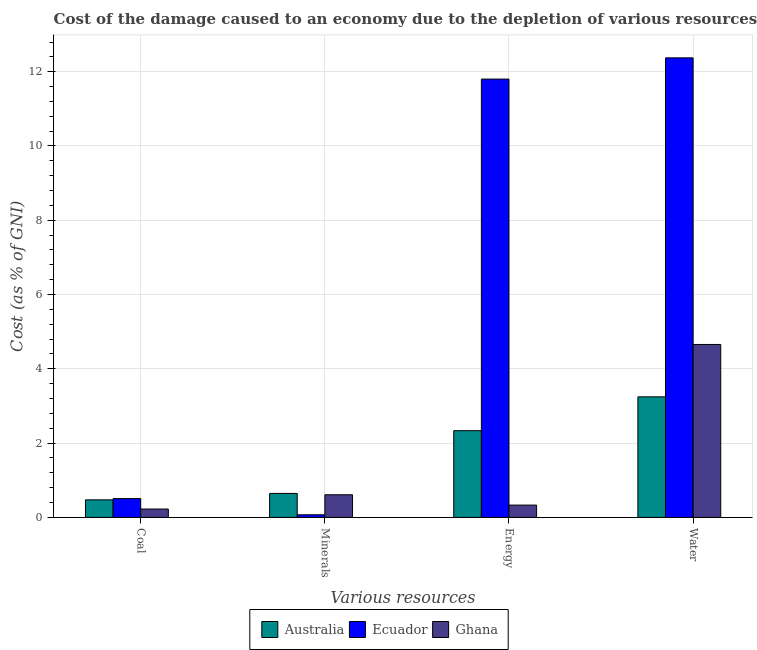How many different coloured bars are there?
Your answer should be compact. 3. What is the label of the 1st group of bars from the left?
Keep it short and to the point. Coal. What is the cost of damage due to depletion of minerals in Ecuador?
Make the answer very short. 0.07. Across all countries, what is the maximum cost of damage due to depletion of energy?
Offer a terse response. 11.8. Across all countries, what is the minimum cost of damage due to depletion of energy?
Offer a terse response. 0.33. In which country was the cost of damage due to depletion of coal maximum?
Offer a terse response. Ecuador. In which country was the cost of damage due to depletion of minerals minimum?
Give a very brief answer. Ecuador. What is the total cost of damage due to depletion of energy in the graph?
Offer a very short reply. 14.47. What is the difference between the cost of damage due to depletion of energy in Ecuador and that in Australia?
Offer a very short reply. 9.47. What is the difference between the cost of damage due to depletion of energy in Ghana and the cost of damage due to depletion of water in Ecuador?
Provide a short and direct response. -12.04. What is the average cost of damage due to depletion of minerals per country?
Ensure brevity in your answer.  0.44. What is the difference between the cost of damage due to depletion of water and cost of damage due to depletion of minerals in Australia?
Keep it short and to the point. 2.6. What is the ratio of the cost of damage due to depletion of water in Ecuador to that in Ghana?
Ensure brevity in your answer.  2.66. What is the difference between the highest and the second highest cost of damage due to depletion of energy?
Your answer should be very brief. 9.47. What is the difference between the highest and the lowest cost of damage due to depletion of water?
Your answer should be compact. 9.13. In how many countries, is the cost of damage due to depletion of energy greater than the average cost of damage due to depletion of energy taken over all countries?
Your answer should be very brief. 1. Is the sum of the cost of damage due to depletion of water in Australia and Ecuador greater than the maximum cost of damage due to depletion of minerals across all countries?
Your response must be concise. Yes. Is it the case that in every country, the sum of the cost of damage due to depletion of minerals and cost of damage due to depletion of coal is greater than the sum of cost of damage due to depletion of energy and cost of damage due to depletion of water?
Your answer should be compact. No. What does the 1st bar from the right in Energy represents?
Ensure brevity in your answer.  Ghana. Is it the case that in every country, the sum of the cost of damage due to depletion of coal and cost of damage due to depletion of minerals is greater than the cost of damage due to depletion of energy?
Your answer should be very brief. No. Are all the bars in the graph horizontal?
Give a very brief answer. No. How many countries are there in the graph?
Make the answer very short. 3. What is the difference between two consecutive major ticks on the Y-axis?
Provide a succinct answer. 2. Does the graph contain any zero values?
Keep it short and to the point. No. Does the graph contain grids?
Your answer should be compact. Yes. How are the legend labels stacked?
Keep it short and to the point. Horizontal. What is the title of the graph?
Your answer should be very brief. Cost of the damage caused to an economy due to the depletion of various resources in 1984 . Does "Bermuda" appear as one of the legend labels in the graph?
Provide a short and direct response. No. What is the label or title of the X-axis?
Your response must be concise. Various resources. What is the label or title of the Y-axis?
Keep it short and to the point. Cost (as % of GNI). What is the Cost (as % of GNI) in Australia in Coal?
Make the answer very short. 0.47. What is the Cost (as % of GNI) in Ecuador in Coal?
Provide a short and direct response. 0.51. What is the Cost (as % of GNI) in Ghana in Coal?
Give a very brief answer. 0.23. What is the Cost (as % of GNI) of Australia in Minerals?
Offer a terse response. 0.65. What is the Cost (as % of GNI) of Ecuador in Minerals?
Your answer should be very brief. 0.07. What is the Cost (as % of GNI) of Ghana in Minerals?
Your answer should be very brief. 0.61. What is the Cost (as % of GNI) of Australia in Energy?
Offer a terse response. 2.33. What is the Cost (as % of GNI) in Ecuador in Energy?
Give a very brief answer. 11.8. What is the Cost (as % of GNI) of Ghana in Energy?
Make the answer very short. 0.33. What is the Cost (as % of GNI) in Australia in Water?
Provide a short and direct response. 3.25. What is the Cost (as % of GNI) of Ecuador in Water?
Provide a succinct answer. 12.37. What is the Cost (as % of GNI) in Ghana in Water?
Your answer should be compact. 4.66. Across all Various resources, what is the maximum Cost (as % of GNI) in Australia?
Your answer should be compact. 3.25. Across all Various resources, what is the maximum Cost (as % of GNI) of Ecuador?
Keep it short and to the point. 12.37. Across all Various resources, what is the maximum Cost (as % of GNI) in Ghana?
Offer a very short reply. 4.66. Across all Various resources, what is the minimum Cost (as % of GNI) of Australia?
Ensure brevity in your answer.  0.47. Across all Various resources, what is the minimum Cost (as % of GNI) of Ecuador?
Provide a succinct answer. 0.07. Across all Various resources, what is the minimum Cost (as % of GNI) of Ghana?
Provide a short and direct response. 0.23. What is the total Cost (as % of GNI) in Australia in the graph?
Offer a terse response. 6.7. What is the total Cost (as % of GNI) of Ecuador in the graph?
Your answer should be compact. 24.75. What is the total Cost (as % of GNI) in Ghana in the graph?
Keep it short and to the point. 5.83. What is the difference between the Cost (as % of GNI) in Australia in Coal and that in Minerals?
Your answer should be very brief. -0.17. What is the difference between the Cost (as % of GNI) in Ecuador in Coal and that in Minerals?
Give a very brief answer. 0.44. What is the difference between the Cost (as % of GNI) of Ghana in Coal and that in Minerals?
Offer a very short reply. -0.38. What is the difference between the Cost (as % of GNI) of Australia in Coal and that in Energy?
Give a very brief answer. -1.86. What is the difference between the Cost (as % of GNI) of Ecuador in Coal and that in Energy?
Your answer should be very brief. -11.3. What is the difference between the Cost (as % of GNI) of Ghana in Coal and that in Energy?
Provide a succinct answer. -0.11. What is the difference between the Cost (as % of GNI) of Australia in Coal and that in Water?
Your answer should be very brief. -2.77. What is the difference between the Cost (as % of GNI) of Ecuador in Coal and that in Water?
Your answer should be compact. -11.87. What is the difference between the Cost (as % of GNI) of Ghana in Coal and that in Water?
Your answer should be compact. -4.43. What is the difference between the Cost (as % of GNI) of Australia in Minerals and that in Energy?
Provide a succinct answer. -1.69. What is the difference between the Cost (as % of GNI) in Ecuador in Minerals and that in Energy?
Provide a short and direct response. -11.73. What is the difference between the Cost (as % of GNI) of Ghana in Minerals and that in Energy?
Keep it short and to the point. 0.28. What is the difference between the Cost (as % of GNI) of Australia in Minerals and that in Water?
Offer a very short reply. -2.6. What is the difference between the Cost (as % of GNI) of Ecuador in Minerals and that in Water?
Make the answer very short. -12.3. What is the difference between the Cost (as % of GNI) of Ghana in Minerals and that in Water?
Offer a terse response. -4.05. What is the difference between the Cost (as % of GNI) of Australia in Energy and that in Water?
Keep it short and to the point. -0.91. What is the difference between the Cost (as % of GNI) in Ecuador in Energy and that in Water?
Your answer should be very brief. -0.57. What is the difference between the Cost (as % of GNI) of Ghana in Energy and that in Water?
Keep it short and to the point. -4.32. What is the difference between the Cost (as % of GNI) in Australia in Coal and the Cost (as % of GNI) in Ecuador in Minerals?
Provide a succinct answer. 0.4. What is the difference between the Cost (as % of GNI) in Australia in Coal and the Cost (as % of GNI) in Ghana in Minerals?
Ensure brevity in your answer.  -0.14. What is the difference between the Cost (as % of GNI) in Ecuador in Coal and the Cost (as % of GNI) in Ghana in Minerals?
Provide a short and direct response. -0.1. What is the difference between the Cost (as % of GNI) of Australia in Coal and the Cost (as % of GNI) of Ecuador in Energy?
Make the answer very short. -11.33. What is the difference between the Cost (as % of GNI) in Australia in Coal and the Cost (as % of GNI) in Ghana in Energy?
Provide a succinct answer. 0.14. What is the difference between the Cost (as % of GNI) in Ecuador in Coal and the Cost (as % of GNI) in Ghana in Energy?
Keep it short and to the point. 0.17. What is the difference between the Cost (as % of GNI) of Australia in Coal and the Cost (as % of GNI) of Ecuador in Water?
Give a very brief answer. -11.9. What is the difference between the Cost (as % of GNI) in Australia in Coal and the Cost (as % of GNI) in Ghana in Water?
Keep it short and to the point. -4.18. What is the difference between the Cost (as % of GNI) in Ecuador in Coal and the Cost (as % of GNI) in Ghana in Water?
Your response must be concise. -4.15. What is the difference between the Cost (as % of GNI) in Australia in Minerals and the Cost (as % of GNI) in Ecuador in Energy?
Make the answer very short. -11.16. What is the difference between the Cost (as % of GNI) in Australia in Minerals and the Cost (as % of GNI) in Ghana in Energy?
Your answer should be compact. 0.31. What is the difference between the Cost (as % of GNI) of Ecuador in Minerals and the Cost (as % of GNI) of Ghana in Energy?
Your answer should be compact. -0.26. What is the difference between the Cost (as % of GNI) in Australia in Minerals and the Cost (as % of GNI) in Ecuador in Water?
Offer a very short reply. -11.73. What is the difference between the Cost (as % of GNI) of Australia in Minerals and the Cost (as % of GNI) of Ghana in Water?
Your answer should be very brief. -4.01. What is the difference between the Cost (as % of GNI) in Ecuador in Minerals and the Cost (as % of GNI) in Ghana in Water?
Keep it short and to the point. -4.59. What is the difference between the Cost (as % of GNI) in Australia in Energy and the Cost (as % of GNI) in Ecuador in Water?
Your response must be concise. -10.04. What is the difference between the Cost (as % of GNI) in Australia in Energy and the Cost (as % of GNI) in Ghana in Water?
Your answer should be compact. -2.32. What is the difference between the Cost (as % of GNI) in Ecuador in Energy and the Cost (as % of GNI) in Ghana in Water?
Make the answer very short. 7.14. What is the average Cost (as % of GNI) of Australia per Various resources?
Offer a terse response. 1.68. What is the average Cost (as % of GNI) of Ecuador per Various resources?
Provide a succinct answer. 6.19. What is the average Cost (as % of GNI) in Ghana per Various resources?
Your response must be concise. 1.46. What is the difference between the Cost (as % of GNI) in Australia and Cost (as % of GNI) in Ecuador in Coal?
Give a very brief answer. -0.03. What is the difference between the Cost (as % of GNI) in Australia and Cost (as % of GNI) in Ghana in Coal?
Offer a terse response. 0.25. What is the difference between the Cost (as % of GNI) of Ecuador and Cost (as % of GNI) of Ghana in Coal?
Ensure brevity in your answer.  0.28. What is the difference between the Cost (as % of GNI) in Australia and Cost (as % of GNI) in Ecuador in Minerals?
Give a very brief answer. 0.58. What is the difference between the Cost (as % of GNI) in Australia and Cost (as % of GNI) in Ghana in Minerals?
Your response must be concise. 0.04. What is the difference between the Cost (as % of GNI) of Ecuador and Cost (as % of GNI) of Ghana in Minerals?
Keep it short and to the point. -0.54. What is the difference between the Cost (as % of GNI) in Australia and Cost (as % of GNI) in Ecuador in Energy?
Offer a terse response. -9.47. What is the difference between the Cost (as % of GNI) in Australia and Cost (as % of GNI) in Ghana in Energy?
Your response must be concise. 2. What is the difference between the Cost (as % of GNI) in Ecuador and Cost (as % of GNI) in Ghana in Energy?
Provide a short and direct response. 11.47. What is the difference between the Cost (as % of GNI) of Australia and Cost (as % of GNI) of Ecuador in Water?
Your answer should be very brief. -9.13. What is the difference between the Cost (as % of GNI) of Australia and Cost (as % of GNI) of Ghana in Water?
Provide a short and direct response. -1.41. What is the difference between the Cost (as % of GNI) of Ecuador and Cost (as % of GNI) of Ghana in Water?
Your answer should be very brief. 7.72. What is the ratio of the Cost (as % of GNI) in Australia in Coal to that in Minerals?
Your response must be concise. 0.73. What is the ratio of the Cost (as % of GNI) in Ecuador in Coal to that in Minerals?
Keep it short and to the point. 7.16. What is the ratio of the Cost (as % of GNI) of Ghana in Coal to that in Minerals?
Offer a terse response. 0.37. What is the ratio of the Cost (as % of GNI) in Australia in Coal to that in Energy?
Provide a short and direct response. 0.2. What is the ratio of the Cost (as % of GNI) in Ecuador in Coal to that in Energy?
Ensure brevity in your answer.  0.04. What is the ratio of the Cost (as % of GNI) in Ghana in Coal to that in Energy?
Your answer should be very brief. 0.68. What is the ratio of the Cost (as % of GNI) of Australia in Coal to that in Water?
Your response must be concise. 0.15. What is the ratio of the Cost (as % of GNI) in Ecuador in Coal to that in Water?
Provide a short and direct response. 0.04. What is the ratio of the Cost (as % of GNI) of Ghana in Coal to that in Water?
Your answer should be very brief. 0.05. What is the ratio of the Cost (as % of GNI) of Australia in Minerals to that in Energy?
Make the answer very short. 0.28. What is the ratio of the Cost (as % of GNI) of Ecuador in Minerals to that in Energy?
Make the answer very short. 0.01. What is the ratio of the Cost (as % of GNI) in Ghana in Minerals to that in Energy?
Ensure brevity in your answer.  1.84. What is the ratio of the Cost (as % of GNI) of Australia in Minerals to that in Water?
Ensure brevity in your answer.  0.2. What is the ratio of the Cost (as % of GNI) of Ecuador in Minerals to that in Water?
Ensure brevity in your answer.  0.01. What is the ratio of the Cost (as % of GNI) of Ghana in Minerals to that in Water?
Offer a terse response. 0.13. What is the ratio of the Cost (as % of GNI) in Australia in Energy to that in Water?
Keep it short and to the point. 0.72. What is the ratio of the Cost (as % of GNI) in Ecuador in Energy to that in Water?
Make the answer very short. 0.95. What is the ratio of the Cost (as % of GNI) in Ghana in Energy to that in Water?
Provide a short and direct response. 0.07. What is the difference between the highest and the second highest Cost (as % of GNI) of Australia?
Your answer should be compact. 0.91. What is the difference between the highest and the second highest Cost (as % of GNI) in Ecuador?
Your response must be concise. 0.57. What is the difference between the highest and the second highest Cost (as % of GNI) in Ghana?
Your answer should be very brief. 4.05. What is the difference between the highest and the lowest Cost (as % of GNI) of Australia?
Offer a terse response. 2.77. What is the difference between the highest and the lowest Cost (as % of GNI) of Ecuador?
Ensure brevity in your answer.  12.3. What is the difference between the highest and the lowest Cost (as % of GNI) of Ghana?
Your answer should be compact. 4.43. 